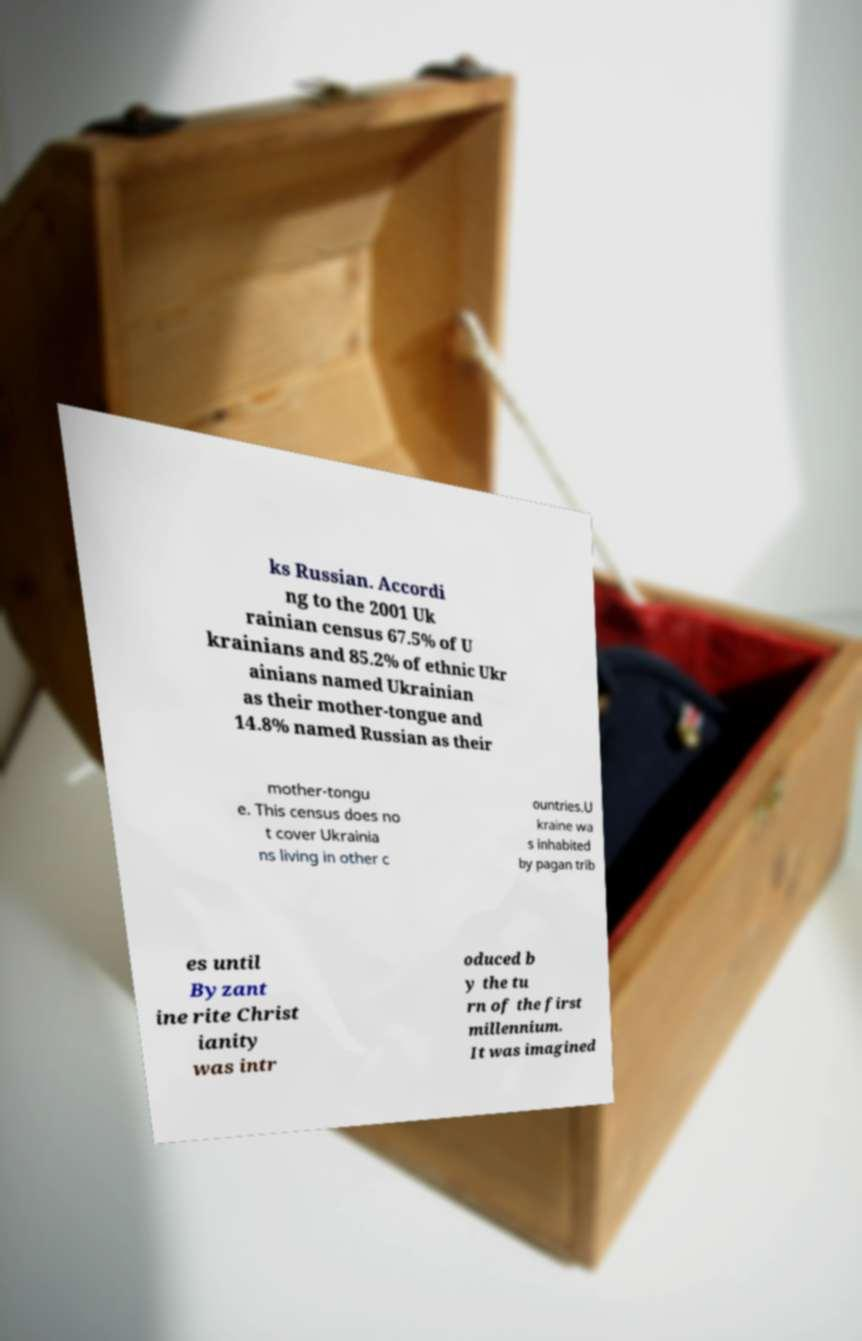I need the written content from this picture converted into text. Can you do that? ks Russian. Accordi ng to the 2001 Uk rainian census 67.5% of U krainians and 85.2% of ethnic Ukr ainians named Ukrainian as their mother-tongue and 14.8% named Russian as their mother-tongu e. This census does no t cover Ukrainia ns living in other c ountries.U kraine wa s inhabited by pagan trib es until Byzant ine rite Christ ianity was intr oduced b y the tu rn of the first millennium. It was imagined 